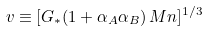<formula> <loc_0><loc_0><loc_500><loc_500>v \equiv [ G _ { * } ( 1 + \alpha _ { A } \alpha _ { B } ) \, M n ] ^ { 1 / 3 }</formula> 